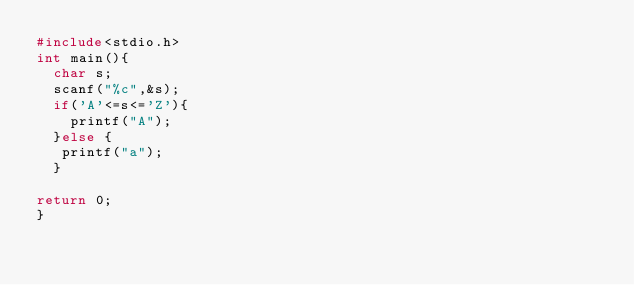<code> <loc_0><loc_0><loc_500><loc_500><_C_>#include<stdio.h>
int main(){
  char s;
  scanf("%c",&s);
  if('A'<=s<='Z'){
    printf("A");
  }else {
   printf("a"); 
  }
  
return 0;
}
</code> 